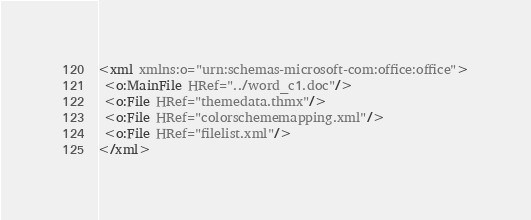Convert code to text. <code><loc_0><loc_0><loc_500><loc_500><_XML_><xml xmlns:o="urn:schemas-microsoft-com:office:office">
 <o:MainFile HRef="../word_c1.doc"/>
 <o:File HRef="themedata.thmx"/>
 <o:File HRef="colorschememapping.xml"/>
 <o:File HRef="filelist.xml"/>
</xml></code> 